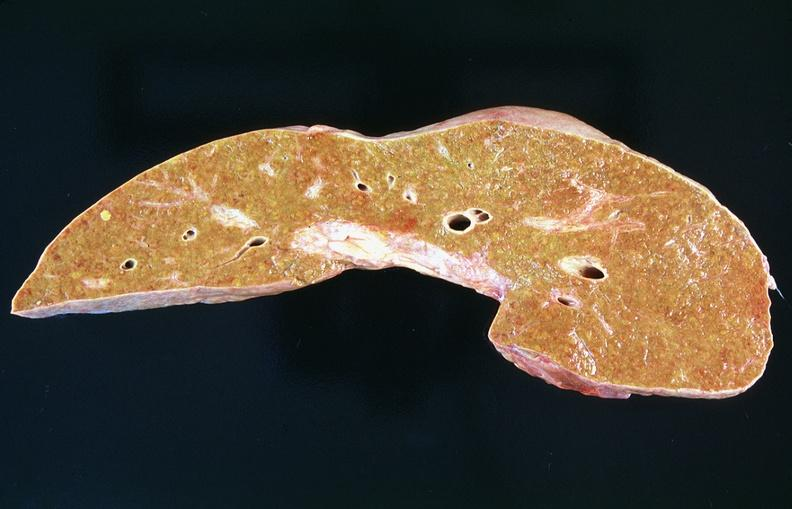s hemangioma present?
Answer the question using a single word or phrase. No 